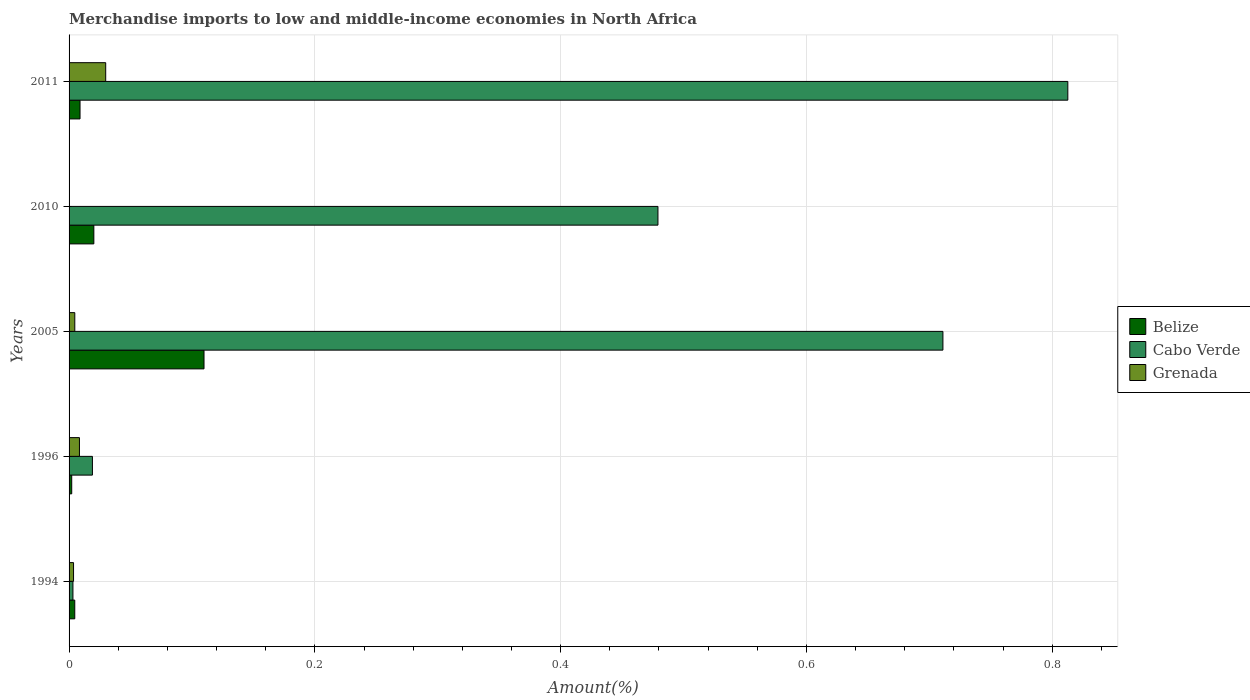How many different coloured bars are there?
Your answer should be compact. 3. How many groups of bars are there?
Ensure brevity in your answer.  5. Are the number of bars per tick equal to the number of legend labels?
Your answer should be very brief. Yes. Are the number of bars on each tick of the Y-axis equal?
Provide a succinct answer. Yes. How many bars are there on the 3rd tick from the bottom?
Ensure brevity in your answer.  3. In how many cases, is the number of bars for a given year not equal to the number of legend labels?
Keep it short and to the point. 0. What is the percentage of amount earned from merchandise imports in Grenada in 2011?
Offer a very short reply. 0.03. Across all years, what is the maximum percentage of amount earned from merchandise imports in Belize?
Keep it short and to the point. 0.11. Across all years, what is the minimum percentage of amount earned from merchandise imports in Grenada?
Ensure brevity in your answer.  6.59134036777357e-5. In which year was the percentage of amount earned from merchandise imports in Cabo Verde maximum?
Your answer should be very brief. 2011. In which year was the percentage of amount earned from merchandise imports in Belize minimum?
Provide a succinct answer. 1996. What is the total percentage of amount earned from merchandise imports in Belize in the graph?
Offer a terse response. 0.15. What is the difference between the percentage of amount earned from merchandise imports in Belize in 2010 and that in 2011?
Your answer should be very brief. 0.01. What is the difference between the percentage of amount earned from merchandise imports in Belize in 1994 and the percentage of amount earned from merchandise imports in Cabo Verde in 2011?
Provide a short and direct response. -0.81. What is the average percentage of amount earned from merchandise imports in Grenada per year?
Ensure brevity in your answer.  0.01. In the year 2005, what is the difference between the percentage of amount earned from merchandise imports in Cabo Verde and percentage of amount earned from merchandise imports in Belize?
Offer a terse response. 0.6. In how many years, is the percentage of amount earned from merchandise imports in Cabo Verde greater than 0.56 %?
Your response must be concise. 2. What is the ratio of the percentage of amount earned from merchandise imports in Grenada in 1994 to that in 2010?
Offer a very short reply. 55.22. What is the difference between the highest and the second highest percentage of amount earned from merchandise imports in Grenada?
Offer a terse response. 0.02. What is the difference between the highest and the lowest percentage of amount earned from merchandise imports in Cabo Verde?
Offer a very short reply. 0.81. In how many years, is the percentage of amount earned from merchandise imports in Cabo Verde greater than the average percentage of amount earned from merchandise imports in Cabo Verde taken over all years?
Offer a terse response. 3. Is the sum of the percentage of amount earned from merchandise imports in Cabo Verde in 2005 and 2011 greater than the maximum percentage of amount earned from merchandise imports in Grenada across all years?
Give a very brief answer. Yes. What does the 2nd bar from the top in 1994 represents?
Provide a succinct answer. Cabo Verde. What does the 3rd bar from the bottom in 1996 represents?
Give a very brief answer. Grenada. How many bars are there?
Your answer should be compact. 15. Are all the bars in the graph horizontal?
Offer a very short reply. Yes. How many years are there in the graph?
Ensure brevity in your answer.  5. Does the graph contain grids?
Your answer should be very brief. Yes. Where does the legend appear in the graph?
Your answer should be compact. Center right. How many legend labels are there?
Keep it short and to the point. 3. What is the title of the graph?
Make the answer very short. Merchandise imports to low and middle-income economies in North Africa. Does "Angola" appear as one of the legend labels in the graph?
Ensure brevity in your answer.  No. What is the label or title of the X-axis?
Offer a terse response. Amount(%). What is the Amount(%) in Belize in 1994?
Offer a terse response. 0. What is the Amount(%) of Cabo Verde in 1994?
Your response must be concise. 0. What is the Amount(%) in Grenada in 1994?
Offer a terse response. 0. What is the Amount(%) of Belize in 1996?
Keep it short and to the point. 0. What is the Amount(%) in Cabo Verde in 1996?
Give a very brief answer. 0.02. What is the Amount(%) of Grenada in 1996?
Your answer should be compact. 0.01. What is the Amount(%) of Belize in 2005?
Your answer should be compact. 0.11. What is the Amount(%) in Cabo Verde in 2005?
Your response must be concise. 0.71. What is the Amount(%) in Grenada in 2005?
Give a very brief answer. 0. What is the Amount(%) in Belize in 2010?
Your answer should be compact. 0.02. What is the Amount(%) in Cabo Verde in 2010?
Your answer should be compact. 0.48. What is the Amount(%) in Grenada in 2010?
Ensure brevity in your answer.  6.59134036777357e-5. What is the Amount(%) in Belize in 2011?
Your response must be concise. 0.01. What is the Amount(%) of Cabo Verde in 2011?
Provide a succinct answer. 0.81. What is the Amount(%) of Grenada in 2011?
Keep it short and to the point. 0.03. Across all years, what is the maximum Amount(%) of Belize?
Make the answer very short. 0.11. Across all years, what is the maximum Amount(%) in Cabo Verde?
Keep it short and to the point. 0.81. Across all years, what is the maximum Amount(%) of Grenada?
Your response must be concise. 0.03. Across all years, what is the minimum Amount(%) in Belize?
Provide a short and direct response. 0. Across all years, what is the minimum Amount(%) of Cabo Verde?
Your answer should be very brief. 0. Across all years, what is the minimum Amount(%) in Grenada?
Provide a succinct answer. 6.59134036777357e-5. What is the total Amount(%) in Belize in the graph?
Offer a very short reply. 0.15. What is the total Amount(%) in Cabo Verde in the graph?
Give a very brief answer. 2.03. What is the total Amount(%) of Grenada in the graph?
Your response must be concise. 0.05. What is the difference between the Amount(%) in Belize in 1994 and that in 1996?
Your answer should be compact. 0. What is the difference between the Amount(%) in Cabo Verde in 1994 and that in 1996?
Make the answer very short. -0.02. What is the difference between the Amount(%) in Grenada in 1994 and that in 1996?
Offer a terse response. -0. What is the difference between the Amount(%) of Belize in 1994 and that in 2005?
Ensure brevity in your answer.  -0.11. What is the difference between the Amount(%) of Cabo Verde in 1994 and that in 2005?
Provide a succinct answer. -0.71. What is the difference between the Amount(%) of Grenada in 1994 and that in 2005?
Offer a terse response. -0. What is the difference between the Amount(%) of Belize in 1994 and that in 2010?
Offer a very short reply. -0.02. What is the difference between the Amount(%) in Cabo Verde in 1994 and that in 2010?
Give a very brief answer. -0.48. What is the difference between the Amount(%) in Grenada in 1994 and that in 2010?
Provide a short and direct response. 0. What is the difference between the Amount(%) of Belize in 1994 and that in 2011?
Your answer should be compact. -0. What is the difference between the Amount(%) in Cabo Verde in 1994 and that in 2011?
Provide a succinct answer. -0.81. What is the difference between the Amount(%) in Grenada in 1994 and that in 2011?
Keep it short and to the point. -0.03. What is the difference between the Amount(%) in Belize in 1996 and that in 2005?
Offer a very short reply. -0.11. What is the difference between the Amount(%) of Cabo Verde in 1996 and that in 2005?
Provide a short and direct response. -0.69. What is the difference between the Amount(%) in Grenada in 1996 and that in 2005?
Provide a succinct answer. 0. What is the difference between the Amount(%) of Belize in 1996 and that in 2010?
Your answer should be compact. -0.02. What is the difference between the Amount(%) in Cabo Verde in 1996 and that in 2010?
Your answer should be very brief. -0.46. What is the difference between the Amount(%) in Grenada in 1996 and that in 2010?
Offer a very short reply. 0.01. What is the difference between the Amount(%) in Belize in 1996 and that in 2011?
Your response must be concise. -0.01. What is the difference between the Amount(%) of Cabo Verde in 1996 and that in 2011?
Make the answer very short. -0.79. What is the difference between the Amount(%) in Grenada in 1996 and that in 2011?
Your answer should be compact. -0.02. What is the difference between the Amount(%) of Belize in 2005 and that in 2010?
Ensure brevity in your answer.  0.09. What is the difference between the Amount(%) in Cabo Verde in 2005 and that in 2010?
Offer a terse response. 0.23. What is the difference between the Amount(%) of Grenada in 2005 and that in 2010?
Make the answer very short. 0. What is the difference between the Amount(%) in Belize in 2005 and that in 2011?
Provide a succinct answer. 0.1. What is the difference between the Amount(%) in Cabo Verde in 2005 and that in 2011?
Your answer should be very brief. -0.1. What is the difference between the Amount(%) of Grenada in 2005 and that in 2011?
Your answer should be compact. -0.03. What is the difference between the Amount(%) in Belize in 2010 and that in 2011?
Provide a succinct answer. 0.01. What is the difference between the Amount(%) of Cabo Verde in 2010 and that in 2011?
Give a very brief answer. -0.33. What is the difference between the Amount(%) of Grenada in 2010 and that in 2011?
Your answer should be compact. -0.03. What is the difference between the Amount(%) of Belize in 1994 and the Amount(%) of Cabo Verde in 1996?
Give a very brief answer. -0.01. What is the difference between the Amount(%) of Belize in 1994 and the Amount(%) of Grenada in 1996?
Keep it short and to the point. -0. What is the difference between the Amount(%) in Cabo Verde in 1994 and the Amount(%) in Grenada in 1996?
Your answer should be very brief. -0.01. What is the difference between the Amount(%) in Belize in 1994 and the Amount(%) in Cabo Verde in 2005?
Provide a succinct answer. -0.71. What is the difference between the Amount(%) of Belize in 1994 and the Amount(%) of Grenada in 2005?
Offer a very short reply. -0. What is the difference between the Amount(%) of Cabo Verde in 1994 and the Amount(%) of Grenada in 2005?
Give a very brief answer. -0. What is the difference between the Amount(%) of Belize in 1994 and the Amount(%) of Cabo Verde in 2010?
Offer a very short reply. -0.47. What is the difference between the Amount(%) in Belize in 1994 and the Amount(%) in Grenada in 2010?
Provide a succinct answer. 0. What is the difference between the Amount(%) in Cabo Verde in 1994 and the Amount(%) in Grenada in 2010?
Make the answer very short. 0. What is the difference between the Amount(%) of Belize in 1994 and the Amount(%) of Cabo Verde in 2011?
Your answer should be compact. -0.81. What is the difference between the Amount(%) in Belize in 1994 and the Amount(%) in Grenada in 2011?
Offer a terse response. -0.03. What is the difference between the Amount(%) in Cabo Verde in 1994 and the Amount(%) in Grenada in 2011?
Offer a terse response. -0.03. What is the difference between the Amount(%) of Belize in 1996 and the Amount(%) of Cabo Verde in 2005?
Ensure brevity in your answer.  -0.71. What is the difference between the Amount(%) of Belize in 1996 and the Amount(%) of Grenada in 2005?
Make the answer very short. -0. What is the difference between the Amount(%) in Cabo Verde in 1996 and the Amount(%) in Grenada in 2005?
Keep it short and to the point. 0.01. What is the difference between the Amount(%) in Belize in 1996 and the Amount(%) in Cabo Verde in 2010?
Offer a terse response. -0.48. What is the difference between the Amount(%) in Belize in 1996 and the Amount(%) in Grenada in 2010?
Your answer should be compact. 0. What is the difference between the Amount(%) in Cabo Verde in 1996 and the Amount(%) in Grenada in 2010?
Offer a very short reply. 0.02. What is the difference between the Amount(%) of Belize in 1996 and the Amount(%) of Cabo Verde in 2011?
Provide a succinct answer. -0.81. What is the difference between the Amount(%) in Belize in 1996 and the Amount(%) in Grenada in 2011?
Provide a succinct answer. -0.03. What is the difference between the Amount(%) of Cabo Verde in 1996 and the Amount(%) of Grenada in 2011?
Offer a very short reply. -0.01. What is the difference between the Amount(%) of Belize in 2005 and the Amount(%) of Cabo Verde in 2010?
Ensure brevity in your answer.  -0.37. What is the difference between the Amount(%) in Belize in 2005 and the Amount(%) in Grenada in 2010?
Offer a terse response. 0.11. What is the difference between the Amount(%) of Cabo Verde in 2005 and the Amount(%) of Grenada in 2010?
Your answer should be very brief. 0.71. What is the difference between the Amount(%) of Belize in 2005 and the Amount(%) of Cabo Verde in 2011?
Keep it short and to the point. -0.7. What is the difference between the Amount(%) of Belize in 2005 and the Amount(%) of Grenada in 2011?
Your response must be concise. 0.08. What is the difference between the Amount(%) of Cabo Verde in 2005 and the Amount(%) of Grenada in 2011?
Your answer should be very brief. 0.68. What is the difference between the Amount(%) in Belize in 2010 and the Amount(%) in Cabo Verde in 2011?
Provide a succinct answer. -0.79. What is the difference between the Amount(%) of Belize in 2010 and the Amount(%) of Grenada in 2011?
Keep it short and to the point. -0.01. What is the difference between the Amount(%) of Cabo Verde in 2010 and the Amount(%) of Grenada in 2011?
Keep it short and to the point. 0.45. What is the average Amount(%) in Belize per year?
Offer a very short reply. 0.03. What is the average Amount(%) of Cabo Verde per year?
Offer a very short reply. 0.41. What is the average Amount(%) of Grenada per year?
Your answer should be compact. 0.01. In the year 1994, what is the difference between the Amount(%) of Belize and Amount(%) of Cabo Verde?
Give a very brief answer. 0. In the year 1994, what is the difference between the Amount(%) of Belize and Amount(%) of Grenada?
Offer a terse response. 0. In the year 1994, what is the difference between the Amount(%) in Cabo Verde and Amount(%) in Grenada?
Provide a short and direct response. -0. In the year 1996, what is the difference between the Amount(%) of Belize and Amount(%) of Cabo Verde?
Offer a very short reply. -0.02. In the year 1996, what is the difference between the Amount(%) of Belize and Amount(%) of Grenada?
Make the answer very short. -0.01. In the year 1996, what is the difference between the Amount(%) of Cabo Verde and Amount(%) of Grenada?
Your answer should be very brief. 0.01. In the year 2005, what is the difference between the Amount(%) in Belize and Amount(%) in Cabo Verde?
Offer a very short reply. -0.6. In the year 2005, what is the difference between the Amount(%) in Belize and Amount(%) in Grenada?
Ensure brevity in your answer.  0.11. In the year 2005, what is the difference between the Amount(%) in Cabo Verde and Amount(%) in Grenada?
Your answer should be compact. 0.71. In the year 2010, what is the difference between the Amount(%) in Belize and Amount(%) in Cabo Verde?
Keep it short and to the point. -0.46. In the year 2010, what is the difference between the Amount(%) in Belize and Amount(%) in Grenada?
Your answer should be very brief. 0.02. In the year 2010, what is the difference between the Amount(%) of Cabo Verde and Amount(%) of Grenada?
Ensure brevity in your answer.  0.48. In the year 2011, what is the difference between the Amount(%) in Belize and Amount(%) in Cabo Verde?
Offer a very short reply. -0.8. In the year 2011, what is the difference between the Amount(%) in Belize and Amount(%) in Grenada?
Provide a succinct answer. -0.02. In the year 2011, what is the difference between the Amount(%) in Cabo Verde and Amount(%) in Grenada?
Ensure brevity in your answer.  0.78. What is the ratio of the Amount(%) in Belize in 1994 to that in 1996?
Give a very brief answer. 2.15. What is the ratio of the Amount(%) in Cabo Verde in 1994 to that in 1996?
Your answer should be compact. 0.17. What is the ratio of the Amount(%) in Grenada in 1994 to that in 1996?
Give a very brief answer. 0.43. What is the ratio of the Amount(%) of Belize in 1994 to that in 2005?
Provide a succinct answer. 0.04. What is the ratio of the Amount(%) of Cabo Verde in 1994 to that in 2005?
Keep it short and to the point. 0. What is the ratio of the Amount(%) in Grenada in 1994 to that in 2005?
Your answer should be very brief. 0.78. What is the ratio of the Amount(%) of Belize in 1994 to that in 2010?
Your response must be concise. 0.23. What is the ratio of the Amount(%) in Cabo Verde in 1994 to that in 2010?
Offer a very short reply. 0.01. What is the ratio of the Amount(%) of Grenada in 1994 to that in 2010?
Your answer should be compact. 55.22. What is the ratio of the Amount(%) in Belize in 1994 to that in 2011?
Give a very brief answer. 0.52. What is the ratio of the Amount(%) in Cabo Verde in 1994 to that in 2011?
Your answer should be very brief. 0. What is the ratio of the Amount(%) in Grenada in 1994 to that in 2011?
Provide a short and direct response. 0.12. What is the ratio of the Amount(%) in Belize in 1996 to that in 2005?
Offer a very short reply. 0.02. What is the ratio of the Amount(%) in Cabo Verde in 1996 to that in 2005?
Offer a very short reply. 0.03. What is the ratio of the Amount(%) in Grenada in 1996 to that in 2005?
Provide a succinct answer. 1.81. What is the ratio of the Amount(%) in Belize in 1996 to that in 2010?
Make the answer very short. 0.11. What is the ratio of the Amount(%) in Cabo Verde in 1996 to that in 2010?
Offer a terse response. 0.04. What is the ratio of the Amount(%) of Grenada in 1996 to that in 2010?
Your answer should be very brief. 128.09. What is the ratio of the Amount(%) in Belize in 1996 to that in 2011?
Make the answer very short. 0.24. What is the ratio of the Amount(%) of Cabo Verde in 1996 to that in 2011?
Ensure brevity in your answer.  0.02. What is the ratio of the Amount(%) of Grenada in 1996 to that in 2011?
Offer a very short reply. 0.28. What is the ratio of the Amount(%) of Belize in 2005 to that in 2010?
Make the answer very short. 5.45. What is the ratio of the Amount(%) in Cabo Verde in 2005 to that in 2010?
Keep it short and to the point. 1.48. What is the ratio of the Amount(%) in Grenada in 2005 to that in 2010?
Provide a short and direct response. 70.66. What is the ratio of the Amount(%) in Belize in 2005 to that in 2011?
Your answer should be compact. 12.32. What is the ratio of the Amount(%) in Cabo Verde in 2005 to that in 2011?
Your answer should be very brief. 0.87. What is the ratio of the Amount(%) of Grenada in 2005 to that in 2011?
Give a very brief answer. 0.16. What is the ratio of the Amount(%) in Belize in 2010 to that in 2011?
Your answer should be very brief. 2.26. What is the ratio of the Amount(%) in Cabo Verde in 2010 to that in 2011?
Your response must be concise. 0.59. What is the ratio of the Amount(%) in Grenada in 2010 to that in 2011?
Your response must be concise. 0. What is the difference between the highest and the second highest Amount(%) in Belize?
Give a very brief answer. 0.09. What is the difference between the highest and the second highest Amount(%) of Cabo Verde?
Offer a very short reply. 0.1. What is the difference between the highest and the second highest Amount(%) in Grenada?
Offer a terse response. 0.02. What is the difference between the highest and the lowest Amount(%) in Belize?
Your answer should be compact. 0.11. What is the difference between the highest and the lowest Amount(%) of Cabo Verde?
Offer a very short reply. 0.81. What is the difference between the highest and the lowest Amount(%) in Grenada?
Give a very brief answer. 0.03. 